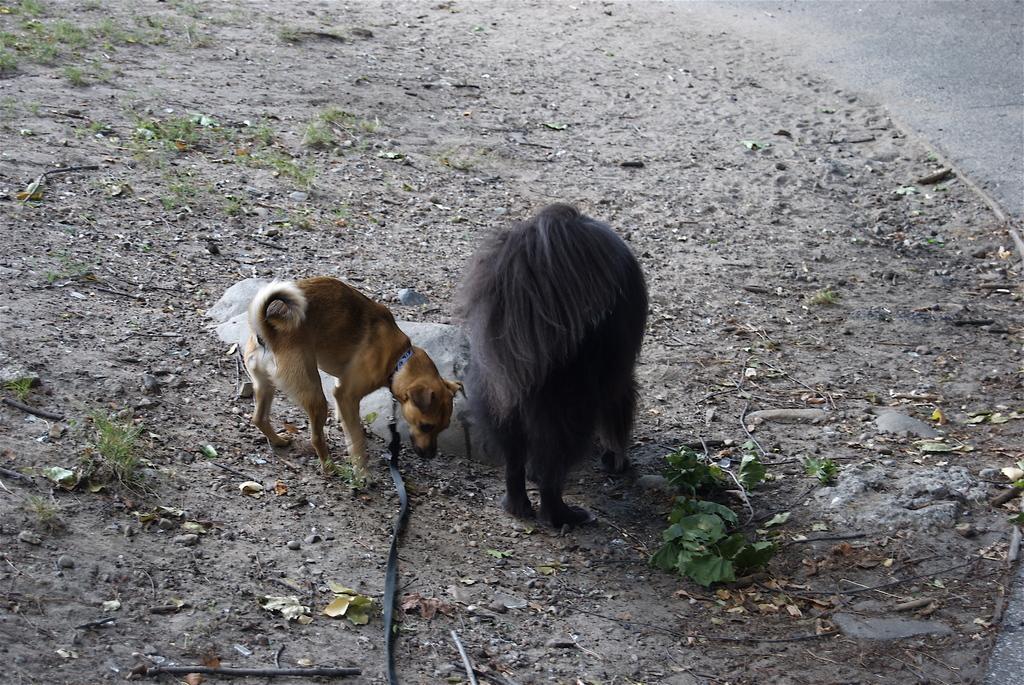Describe this image in one or two sentences. Here in this picture we can see two dogs present on the ground over there and we can see some leaves and grass present on the ground here and there, in the middle we can see a stone present and the dog on the left side is having a belt on its neck present over there. 